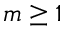<formula> <loc_0><loc_0><loc_500><loc_500>m \geq 1</formula> 